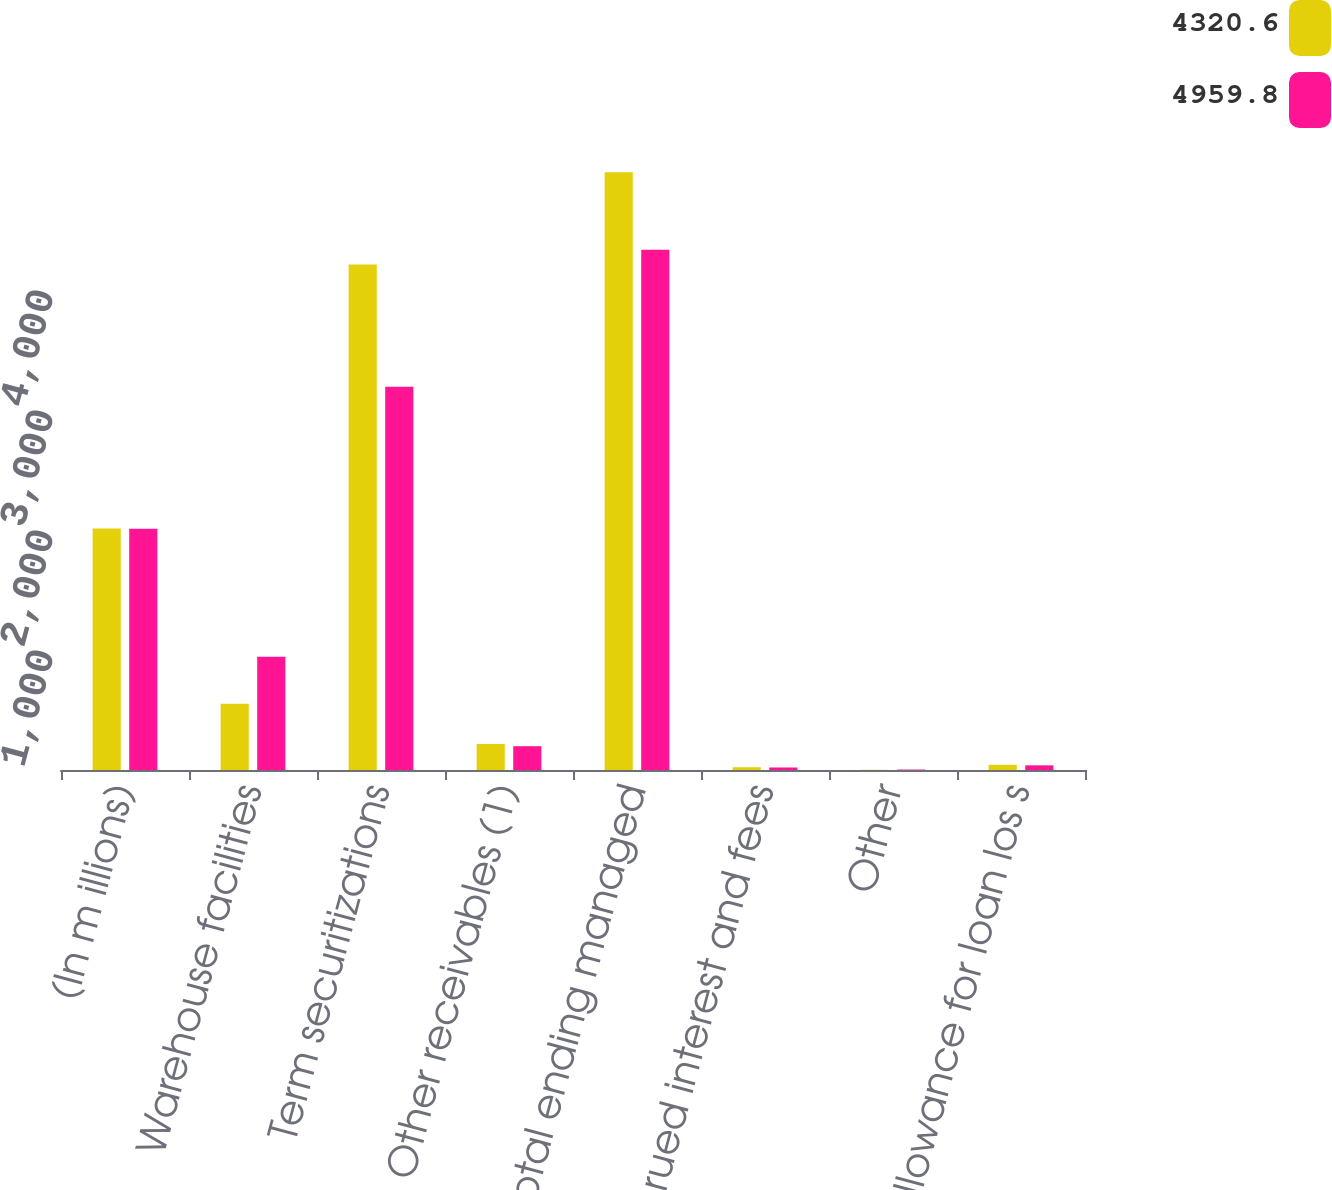Convert chart. <chart><loc_0><loc_0><loc_500><loc_500><stacked_bar_chart><ecel><fcel>(In m illions)<fcel>Warehouse facilities<fcel>Term securitizations<fcel>Other receivables (1)<fcel>Total ending managed<fcel>Accrued interest and fees<fcel>Other<fcel>Les s allowance for loan los s<nl><fcel>4320.6<fcel>2012<fcel>553<fcel>4211.8<fcel>217<fcel>4981.8<fcel>23.1<fcel>1.8<fcel>43.3<nl><fcel>4959.8<fcel>2011<fcel>943<fcel>3193.1<fcel>198.5<fcel>4334.6<fcel>20.9<fcel>4<fcel>38.9<nl></chart> 